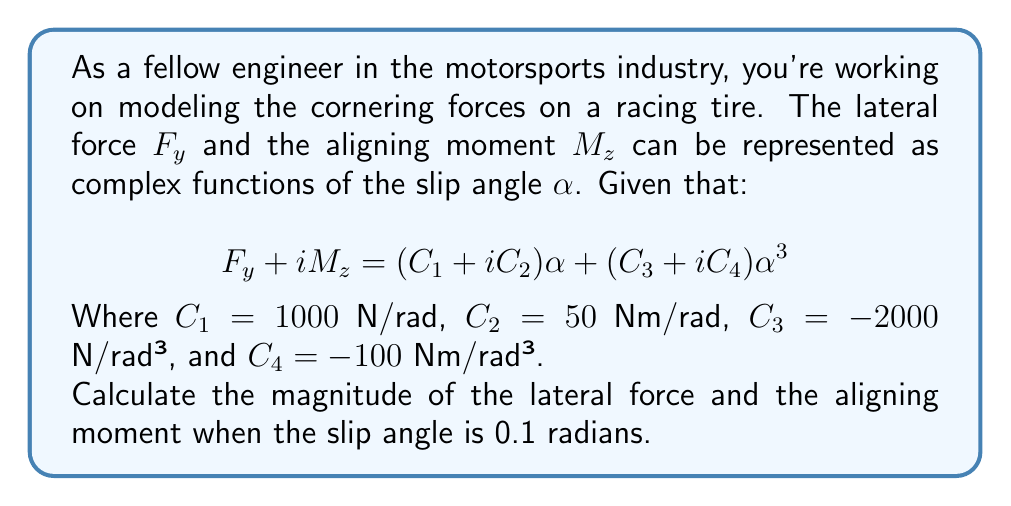Solve this math problem. Let's approach this step-by-step:

1) First, we need to substitute the given values into the complex function:

   $$F_y + iM_z = (1000 + 50i)\alpha + (-2000 - 100i)\alpha^3$$

2) Now, let's substitute $\alpha = 0.1$ rad:

   $$F_y + iM_z = (1000 + 50i)(0.1) + (-2000 - 100i)(0.1)^3$$

3) Simplify the powers:

   $$F_y + iM_z = (1000 + 50i)(0.1) + (-2000 - 100i)(0.001)$$

4) Multiply:

   $$F_y + iM_z = (100 + 5i) + (-2 - 0.1i)$$

5) Combine real and imaginary parts:

   $$F_y + iM_z = 98 + 4.9i$$

6) The real part represents the lateral force $F_y$, and the imaginary part represents the aligning moment $M_z$:

   $F_y = 98$ N
   $M_z = 4.9$ Nm

7) To find the magnitudes, we use the absolute value:

   $|F_y| = |98| = 98$ N
   $|M_z| = |4.9| = 4.9$ Nm
Answer: The magnitude of the lateral force is 98 N, and the magnitude of the aligning moment is 4.9 Nm. 